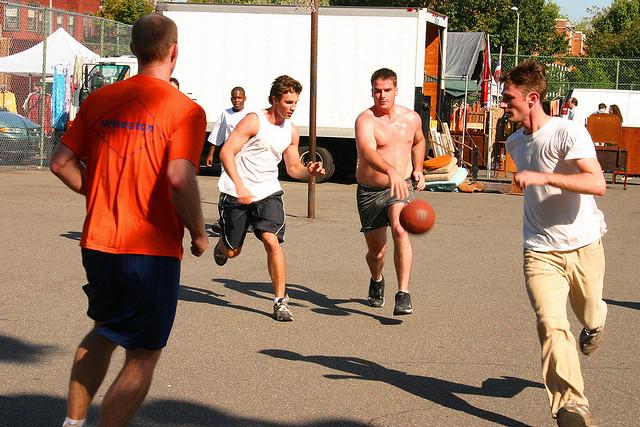What are they playing?
Give a very brief answer. Basketball. Are any of these players shirtless?
Write a very short answer. Yes. What colors are in the awnings?
Quick response, please. White. What color is the ball the kid is trying to hit?
Concise answer only. Orange. What sport is that?
Short answer required. Basketball. What is the person hitting?
Write a very short answer. Basketball. What is directly behind the players?
Concise answer only. Truck. 